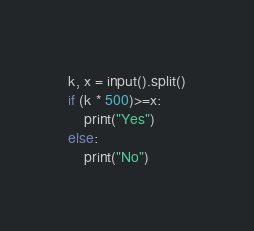<code> <loc_0><loc_0><loc_500><loc_500><_Python_>k, x = input().split()
if (k * 500)>=x:
    print("Yes")
else:
    print("No")</code> 